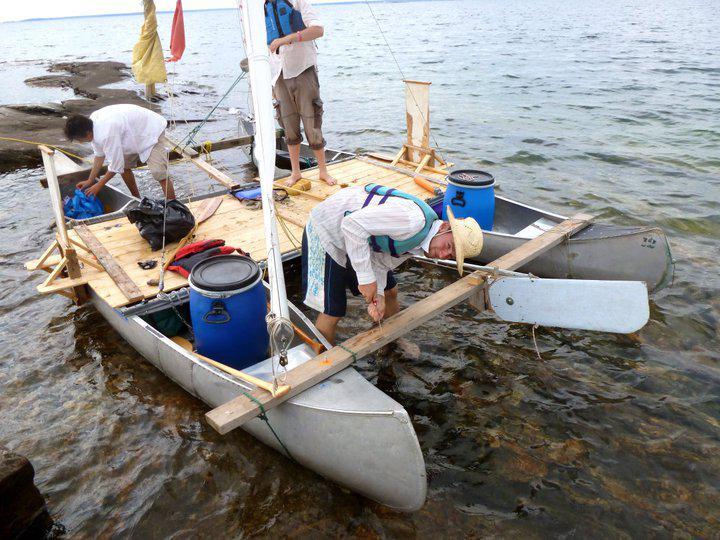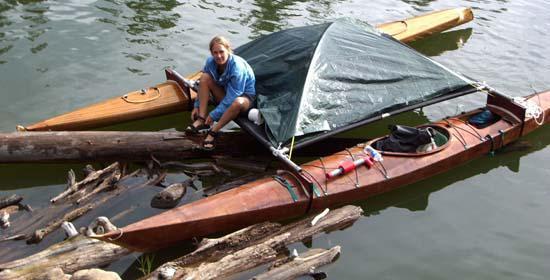The first image is the image on the left, the second image is the image on the right. Analyze the images presented: Is the assertion "In one picture the canoes are in the water and in the other picture the canoes are not in the water." valid? Answer yes or no. No. 